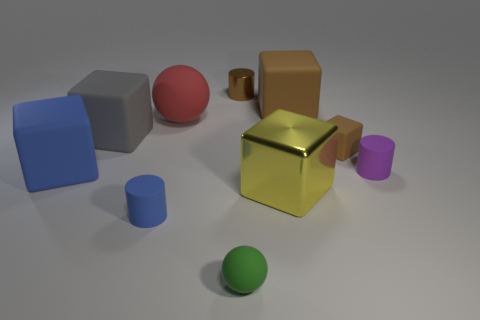What number of things are small cylinders that are behind the tiny blue rubber thing or shiny things on the right side of the small brown metallic cylinder?
Your answer should be very brief. 3. There is a ball that is in front of the matte cylinder left of the large matte block that is on the right side of the large ball; what is its size?
Your response must be concise. Small. Are there the same number of spheres that are to the right of the green thing and large metallic blocks?
Give a very brief answer. No. Are there any other things that have the same shape as the large red object?
Keep it short and to the point. Yes. Is the shape of the big gray matte object the same as the tiny object that is on the left side of the small matte ball?
Your response must be concise. No. What is the size of the gray thing that is the same shape as the yellow metallic thing?
Provide a succinct answer. Large. What number of other objects are the same material as the red ball?
Provide a short and direct response. 7. What material is the small ball?
Give a very brief answer. Rubber. There is a rubber cylinder that is to the left of the tiny brown cube; is its color the same as the sphere that is behind the tiny blue rubber object?
Keep it short and to the point. No. Is the number of small brown objects that are to the right of the large brown matte thing greater than the number of brown cylinders?
Offer a very short reply. No. 